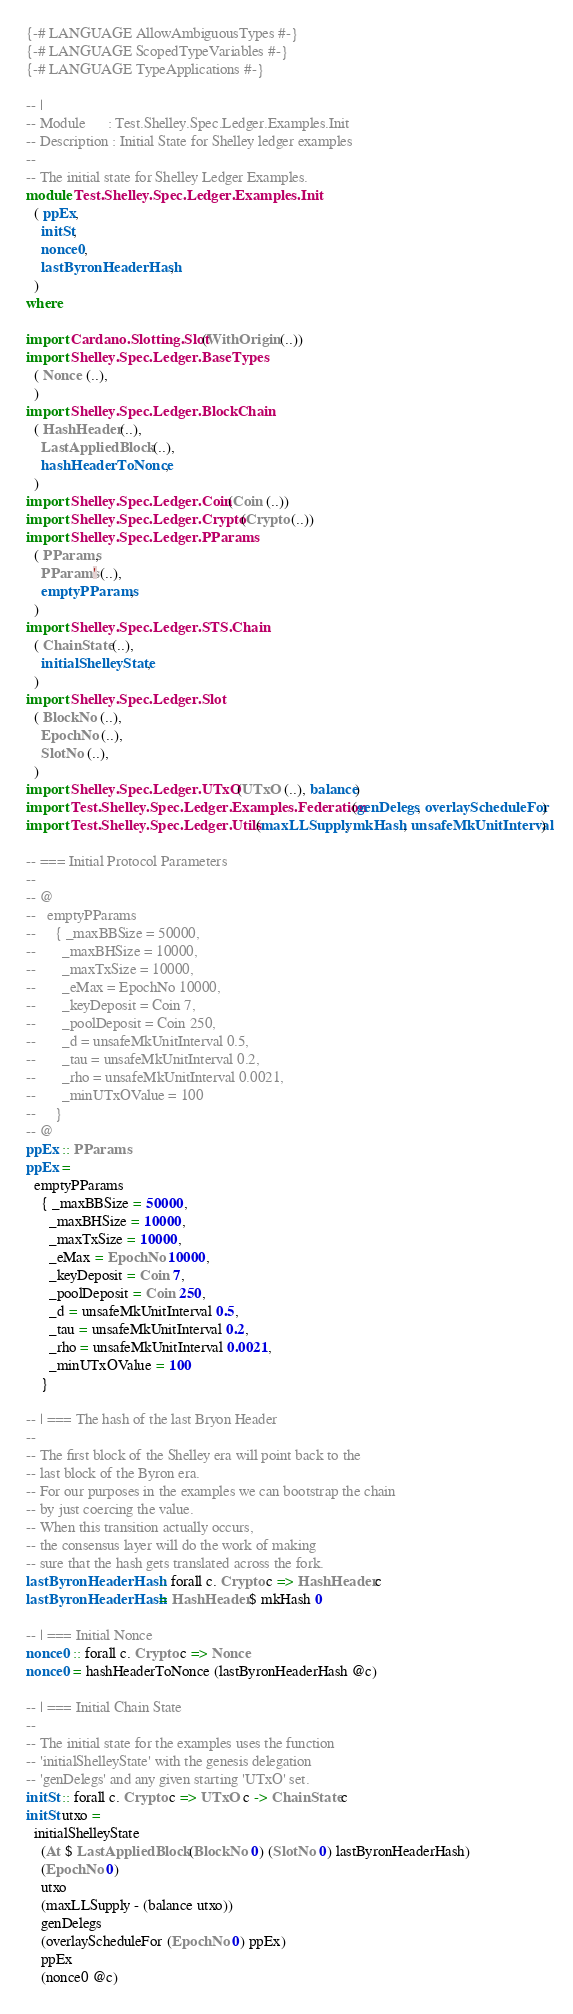Convert code to text. <code><loc_0><loc_0><loc_500><loc_500><_Haskell_>{-# LANGUAGE AllowAmbiguousTypes #-}
{-# LANGUAGE ScopedTypeVariables #-}
{-# LANGUAGE TypeApplications #-}

-- |
-- Module      : Test.Shelley.Spec.Ledger.Examples.Init
-- Description : Initial State for Shelley ledger examples
--
-- The initial state for Shelley Ledger Examples.
module Test.Shelley.Spec.Ledger.Examples.Init
  ( ppEx,
    initSt,
    nonce0,
    lastByronHeaderHash,
  )
where

import Cardano.Slotting.Slot (WithOrigin (..))
import Shelley.Spec.Ledger.BaseTypes
  ( Nonce (..),
  )
import Shelley.Spec.Ledger.BlockChain
  ( HashHeader (..),
    LastAppliedBlock (..),
    hashHeaderToNonce,
  )
import Shelley.Spec.Ledger.Coin (Coin (..))
import Shelley.Spec.Ledger.Crypto (Crypto (..))
import Shelley.Spec.Ledger.PParams
  ( PParams,
    PParams' (..),
    emptyPParams,
  )
import Shelley.Spec.Ledger.STS.Chain
  ( ChainState (..),
    initialShelleyState,
  )
import Shelley.Spec.Ledger.Slot
  ( BlockNo (..),
    EpochNo (..),
    SlotNo (..),
  )
import Shelley.Spec.Ledger.UTxO (UTxO (..), balance)
import Test.Shelley.Spec.Ledger.Examples.Federation (genDelegs, overlayScheduleFor)
import Test.Shelley.Spec.Ledger.Utils (maxLLSupply, mkHash, unsafeMkUnitInterval)

-- === Initial Protocol Parameters
--
-- @
--   emptyPParams
--     { _maxBBSize = 50000,
--       _maxBHSize = 10000,
--       _maxTxSize = 10000,
--       _eMax = EpochNo 10000,
--       _keyDeposit = Coin 7,
--       _poolDeposit = Coin 250,
--       _d = unsafeMkUnitInterval 0.5,
--       _tau = unsafeMkUnitInterval 0.2,
--       _rho = unsafeMkUnitInterval 0.0021,
--       _minUTxOValue = 100
--     }
-- @
ppEx :: PParams
ppEx =
  emptyPParams
    { _maxBBSize = 50000,
      _maxBHSize = 10000,
      _maxTxSize = 10000,
      _eMax = EpochNo 10000,
      _keyDeposit = Coin 7,
      _poolDeposit = Coin 250,
      _d = unsafeMkUnitInterval 0.5,
      _tau = unsafeMkUnitInterval 0.2,
      _rho = unsafeMkUnitInterval 0.0021,
      _minUTxOValue = 100
    }

-- | === The hash of the last Bryon Header
--
-- The first block of the Shelley era will point back to the
-- last block of the Byron era.
-- For our purposes in the examples we can bootstrap the chain
-- by just coercing the value.
-- When this transition actually occurs,
-- the consensus layer will do the work of making
-- sure that the hash gets translated across the fork.
lastByronHeaderHash :: forall c. Crypto c => HashHeader c
lastByronHeaderHash = HashHeader $ mkHash 0

-- | === Initial Nonce
nonce0 :: forall c. Crypto c => Nonce
nonce0 = hashHeaderToNonce (lastByronHeaderHash @c)

-- | === Initial Chain State
--
-- The initial state for the examples uses the function
-- 'initialShelleyState' with the genesis delegation
-- 'genDelegs' and any given starting 'UTxO' set.
initSt :: forall c. Crypto c => UTxO c -> ChainState c
initSt utxo =
  initialShelleyState
    (At $ LastAppliedBlock (BlockNo 0) (SlotNo 0) lastByronHeaderHash)
    (EpochNo 0)
    utxo
    (maxLLSupply - (balance utxo))
    genDelegs
    (overlayScheduleFor (EpochNo 0) ppEx)
    ppEx
    (nonce0 @c)
</code> 